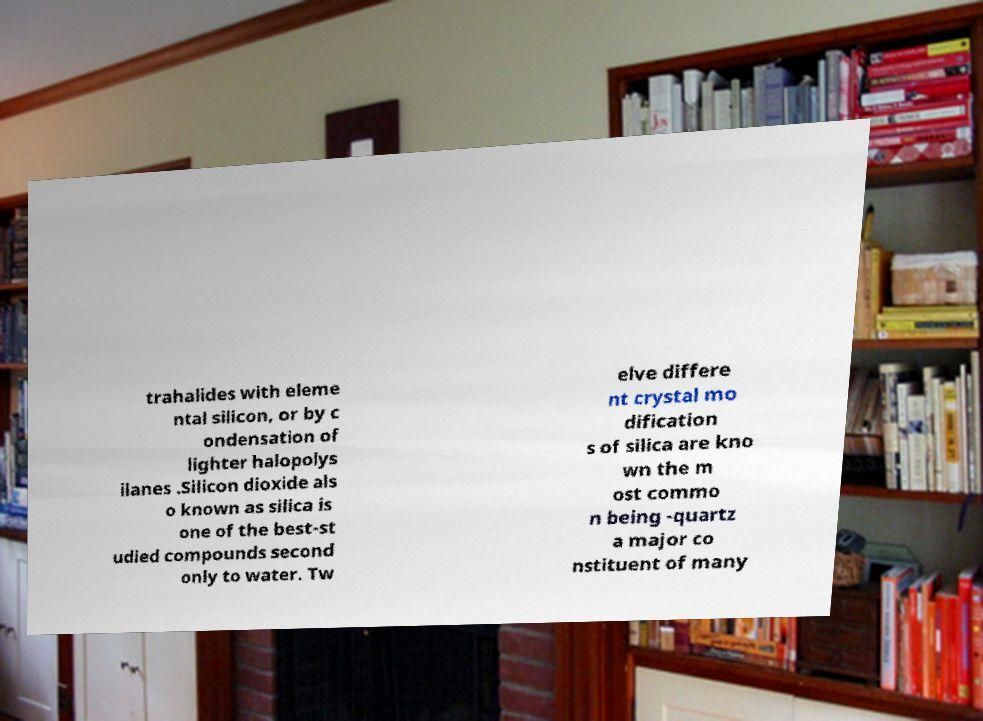Please read and relay the text visible in this image. What does it say? trahalides with eleme ntal silicon, or by c ondensation of lighter halopolys ilanes .Silicon dioxide als o known as silica is one of the best-st udied compounds second only to water. Tw elve differe nt crystal mo dification s of silica are kno wn the m ost commo n being -quartz a major co nstituent of many 